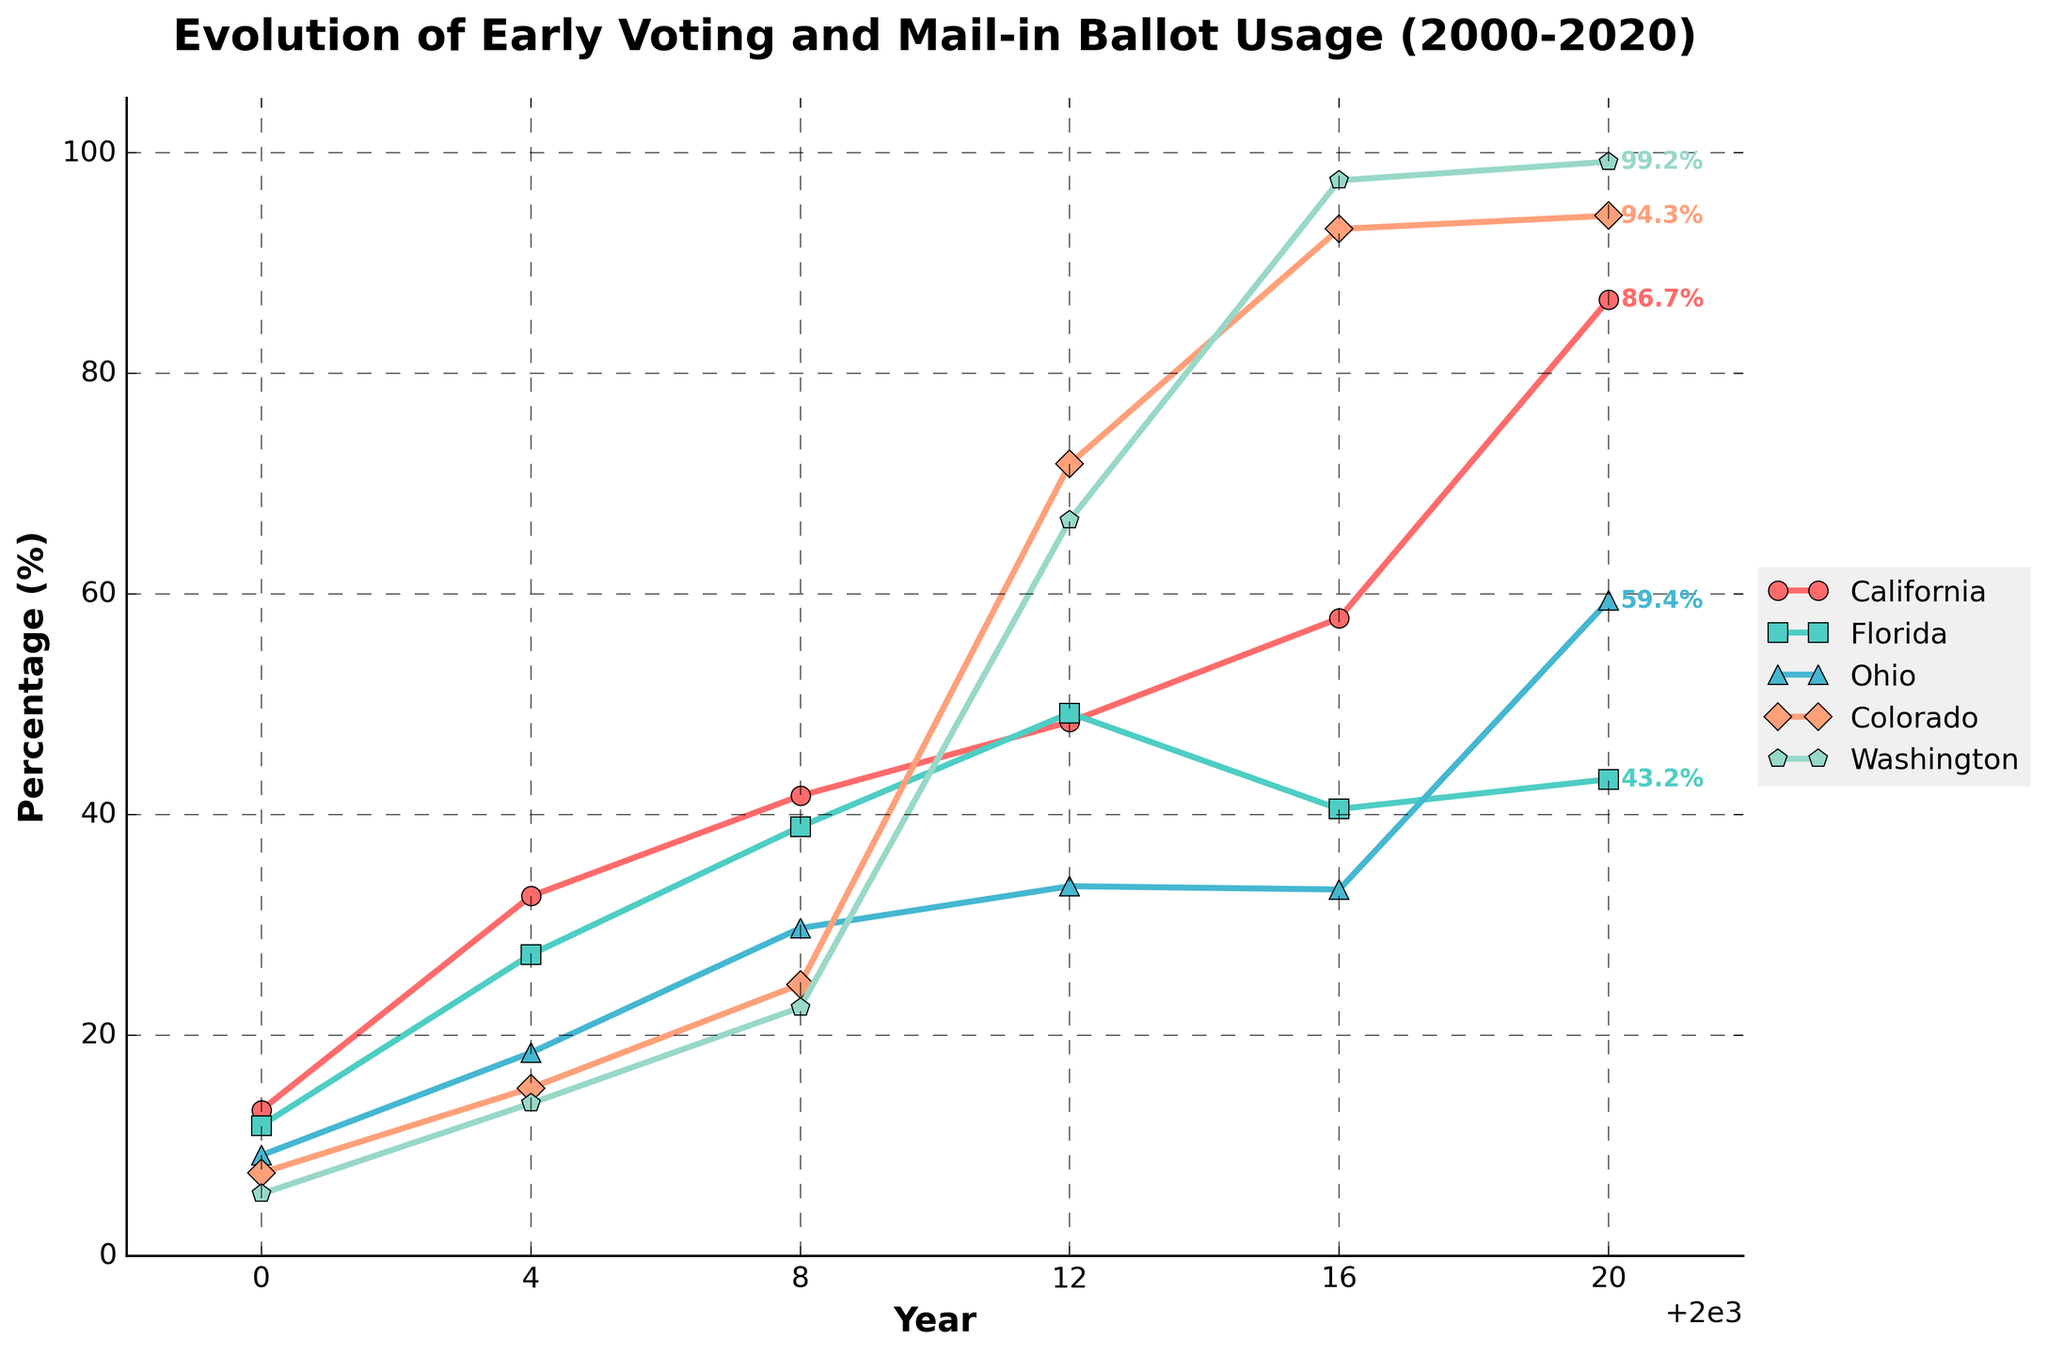What is the trend of mail-in ballot usage in California from 2000 to 2020? By observing the California line, it consistently rises from 13.2% in 2000 to 86.7% in 2020, indicating a steady increase in mail-in ballot usage.
Answer: Increasing Which state had the largest increase in early voting and mail-in ballot usage from 2016 to 2020? By comparing the end-points of 2016 and 2020 for all states, Washington shows the largest increase jumping from 97.5% to 99.2%.
Answer: Washington In which year did Florida and Ohio have the same early voting and mail-in ballot usage? Florida and Ohio both show the same early voting and mail-in ballot usage in 2016, with both states at around 33.2%.
Answer: 2016 What is the percentage difference in mail-in ballot usage between Colorado and Florida in 2020? In 2020, Colorado was at 94.3% while Florida was at 43.2%. The difference is calculated by 94.3% - 43.2% = 51.1%.
Answer: 51.1% Which state had the highest early voting and mail-in ballot usage in 2012? Observing the lines in 2012, Colorado had the highest percentage at 71.8%.
Answer: Colorado Compare the early voting and mail-in ballot usage of Washington and Ohio in 2004 and describe the difference. In 2004, Washington was at 13.8% and Ohio was at 18.4%. The difference is calculated by 18.4% - 13.8% = 4.6%, with Ohio having higher usage.
Answer: 4.6% Calculate the average early voting and mail-in ballot usage in 2020 across all states shown. Summing up the percentages: 86.7 + 43.2 + 59.4 + 94.3 + 99.2 = 382.8. There are 5 states, so the average is 382.8 / 5 = 76.56%.
Answer: 76.56% Which state's early voting and mail-in ballot usage percentage was closest to the overall average in 2020? The calculated average for 2020 is 76.56%. Comparing each state to this, Ohio (59.4%) is the closest.
Answer: Ohio 